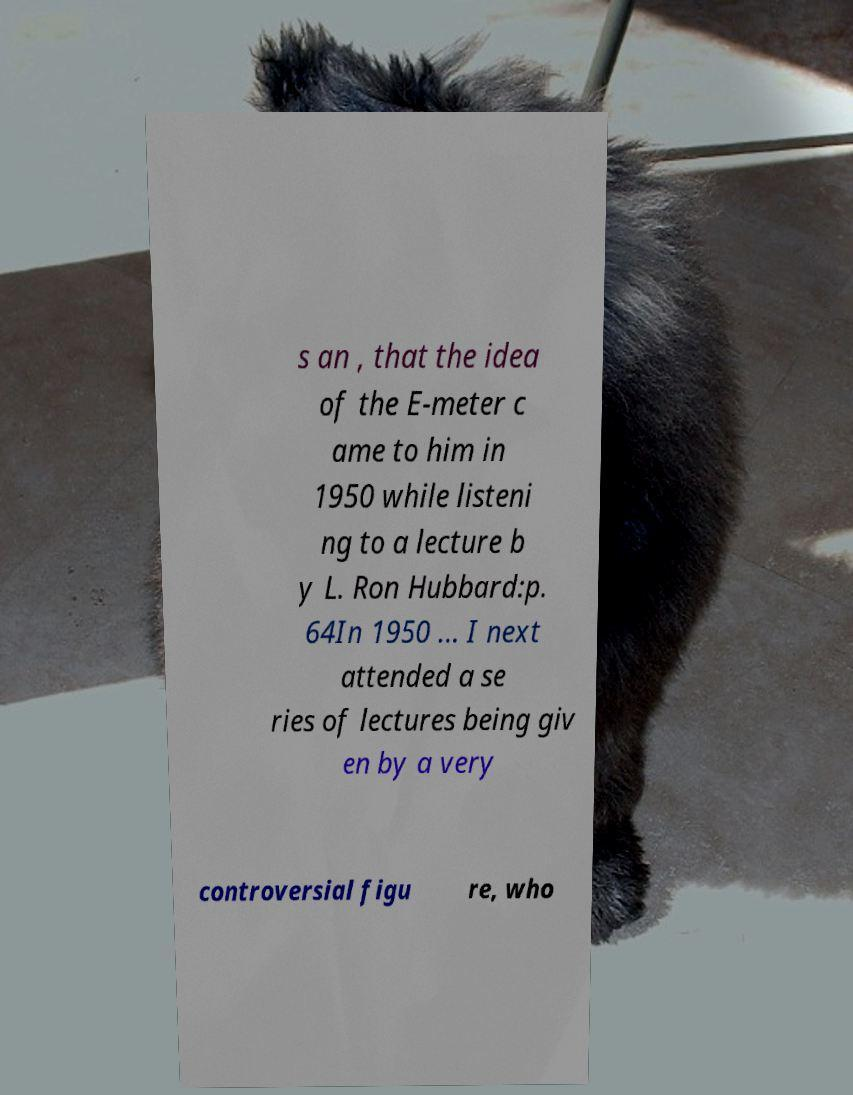There's text embedded in this image that I need extracted. Can you transcribe it verbatim? s an , that the idea of the E-meter c ame to him in 1950 while listeni ng to a lecture b y L. Ron Hubbard:p. 64In 1950 ... I next attended a se ries of lectures being giv en by a very controversial figu re, who 